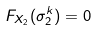Convert formula to latex. <formula><loc_0><loc_0><loc_500><loc_500>F _ { X _ { 2 } } ( \sigma _ { 2 } ^ { k } ) = 0</formula> 